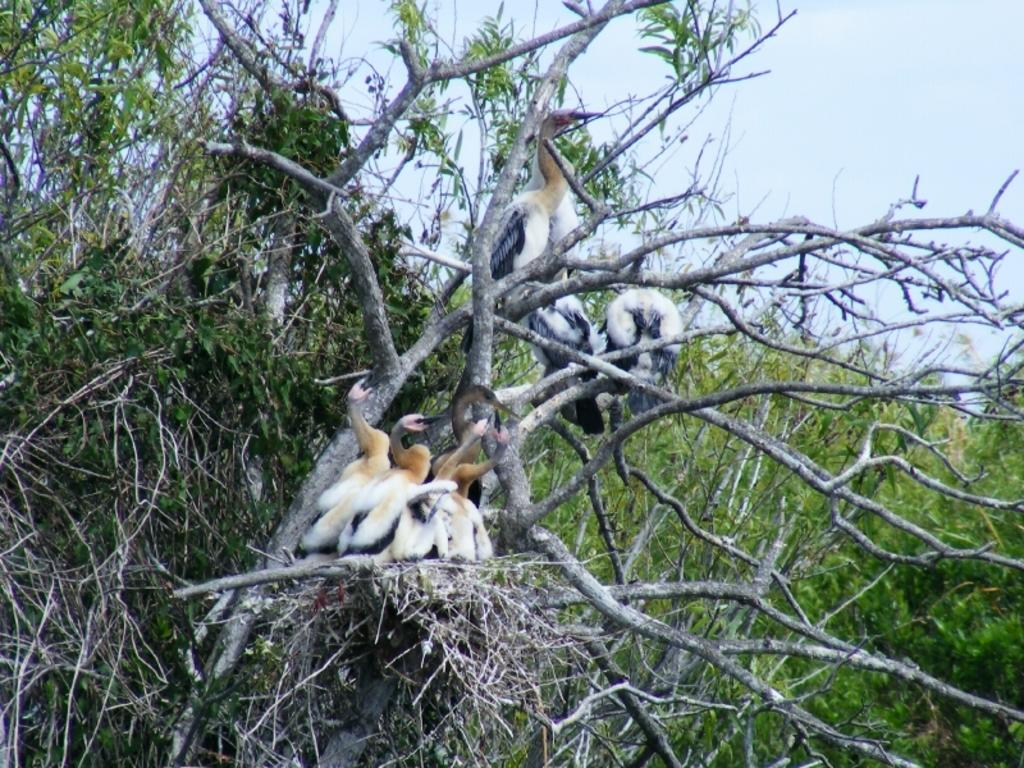What type of animals can be seen in the image? Birds can be seen in the image. Where are the birds located in the image? The birds are on trees. What time of day is it in the image, according to the bird's stomach? There is no information about the bird's stomach or the time of day in the image. 